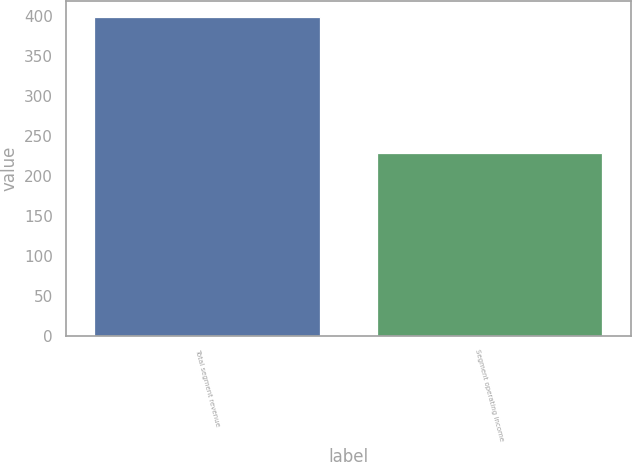<chart> <loc_0><loc_0><loc_500><loc_500><bar_chart><fcel>Total segment revenue<fcel>Segment operating income<nl><fcel>399<fcel>228<nl></chart> 